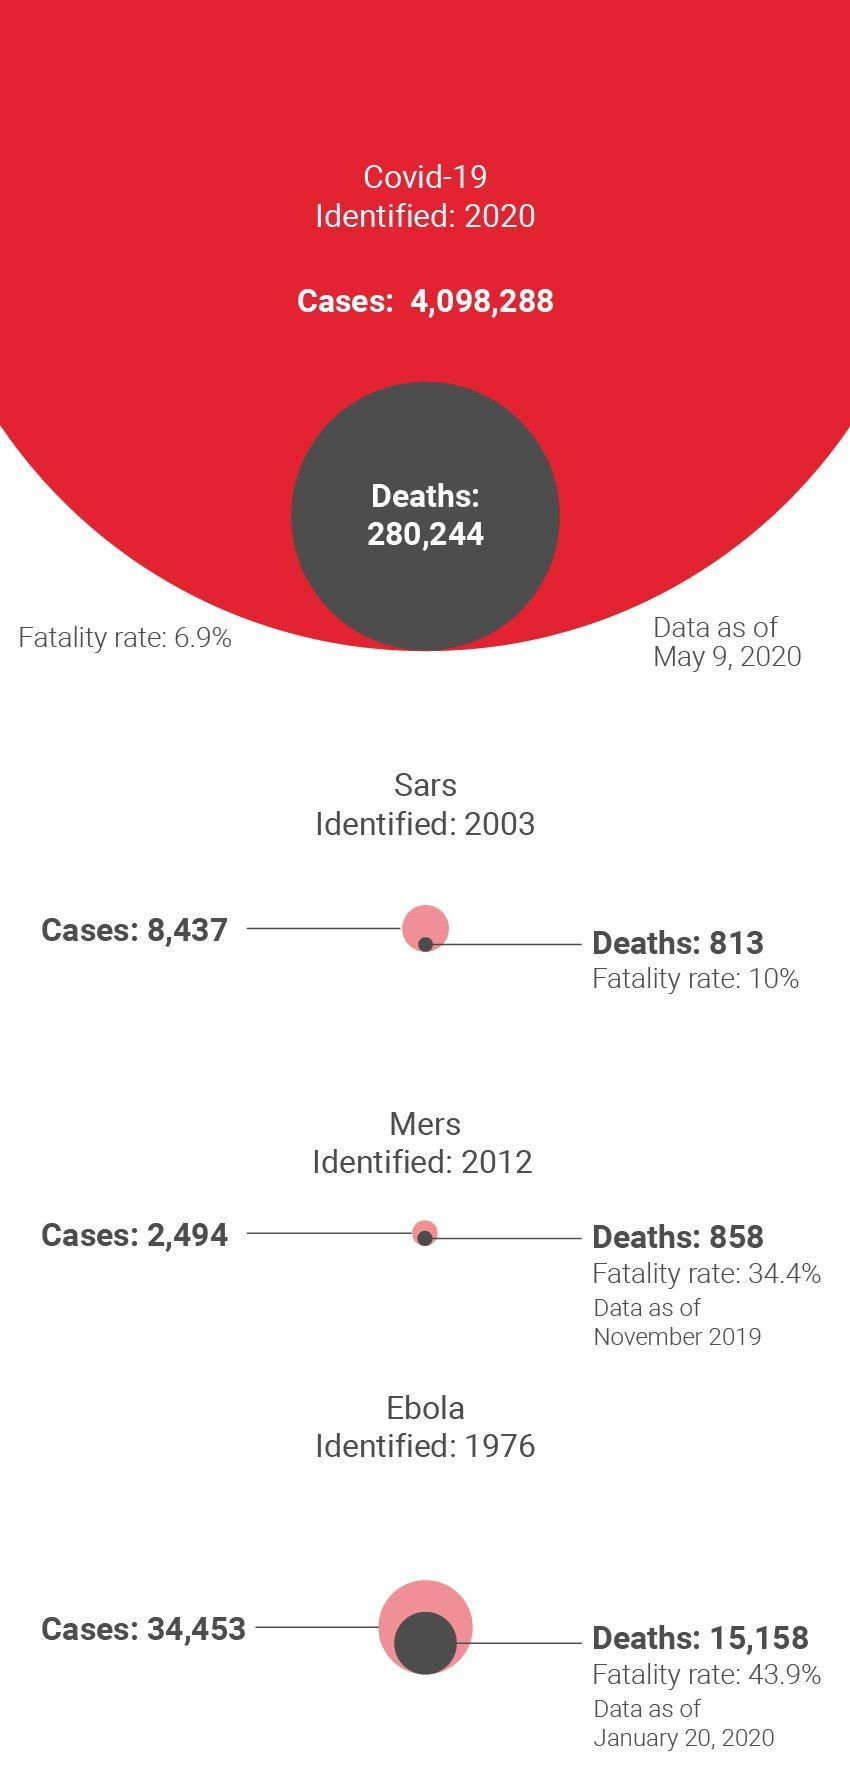Which of the diseases listed in this image show the lowest number of cases detected?
Answer the question with a short phrase. Mers Which disease has a fatality rate of 43.9%? Ebola What is the number of deaths reported due to Ebola? 15,158 Which of the diseases listed in this image has the lowest fatality rate? Covid-19 Which disease was identified in the early 2000s? Sars Which of the diseases in this image was identified the earliest? Ebola Which disease has a fatality rate of 34.4%? Mers What is the fatality rate of Sars? 10% For which disease is the lowest number of deaths reported? Sars What is the fatality rate of Covid-19? 6.9% 